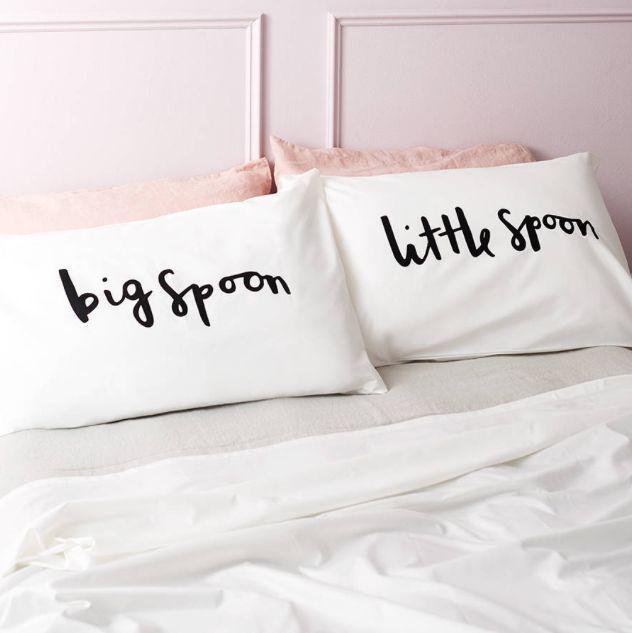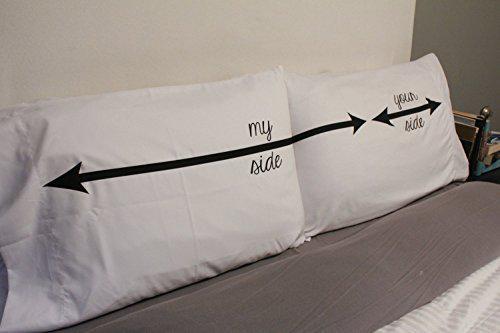The first image is the image on the left, the second image is the image on the right. Considering the images on both sides, is "Each image shows a pair of pillows with text only, side-by-side on a bed with all-white bedding." valid? Answer yes or no. No. The first image is the image on the left, the second image is the image on the right. For the images shown, is this caption "The writing in the right image is cursive." true? Answer yes or no. Yes. 